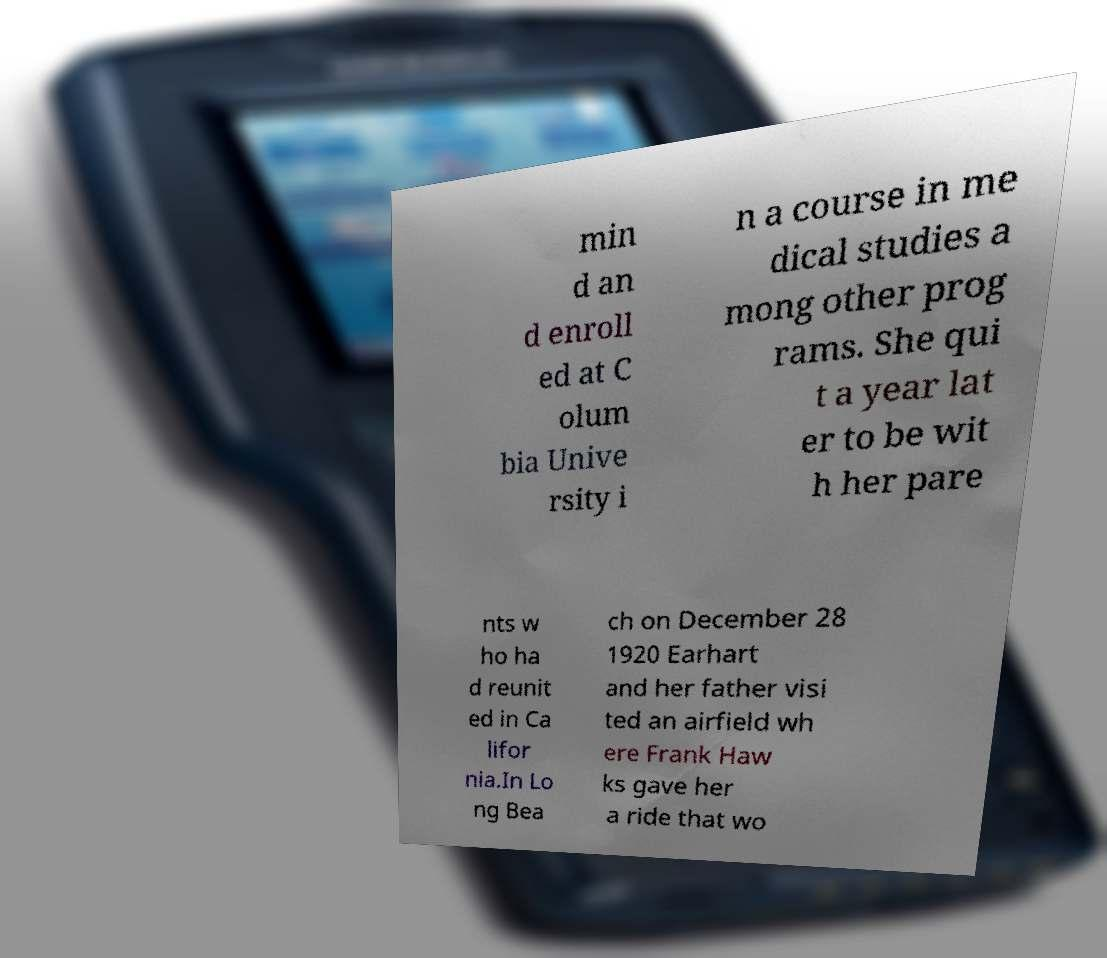Can you read and provide the text displayed in the image?This photo seems to have some interesting text. Can you extract and type it out for me? min d an d enroll ed at C olum bia Unive rsity i n a course in me dical studies a mong other prog rams. She qui t a year lat er to be wit h her pare nts w ho ha d reunit ed in Ca lifor nia.In Lo ng Bea ch on December 28 1920 Earhart and her father visi ted an airfield wh ere Frank Haw ks gave her a ride that wo 